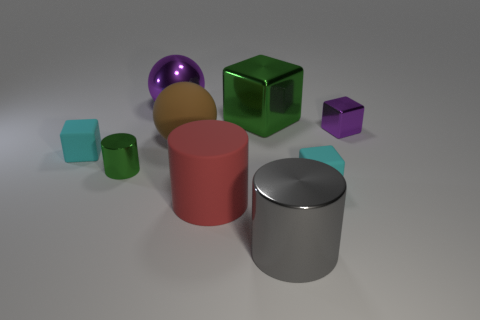Subtract all blocks. How many objects are left? 5 Subtract all large shiny objects. Subtract all small red blocks. How many objects are left? 6 Add 7 shiny cylinders. How many shiny cylinders are left? 9 Add 4 small gray cylinders. How many small gray cylinders exist? 4 Subtract 0 purple cylinders. How many objects are left? 9 